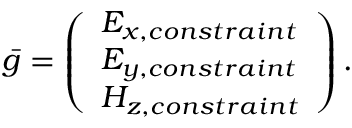Convert formula to latex. <formula><loc_0><loc_0><loc_500><loc_500>{ \bar { g } } = \left ( { \begin{array} { l } { E _ { x , c o n s t r a i n t } } \\ { E _ { y , c o n s t r a i n t } } \\ { H _ { z , c o n s t r a i n t } } \end{array} } \right ) .</formula> 